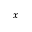<formula> <loc_0><loc_0><loc_500><loc_500>^ { x }</formula> 